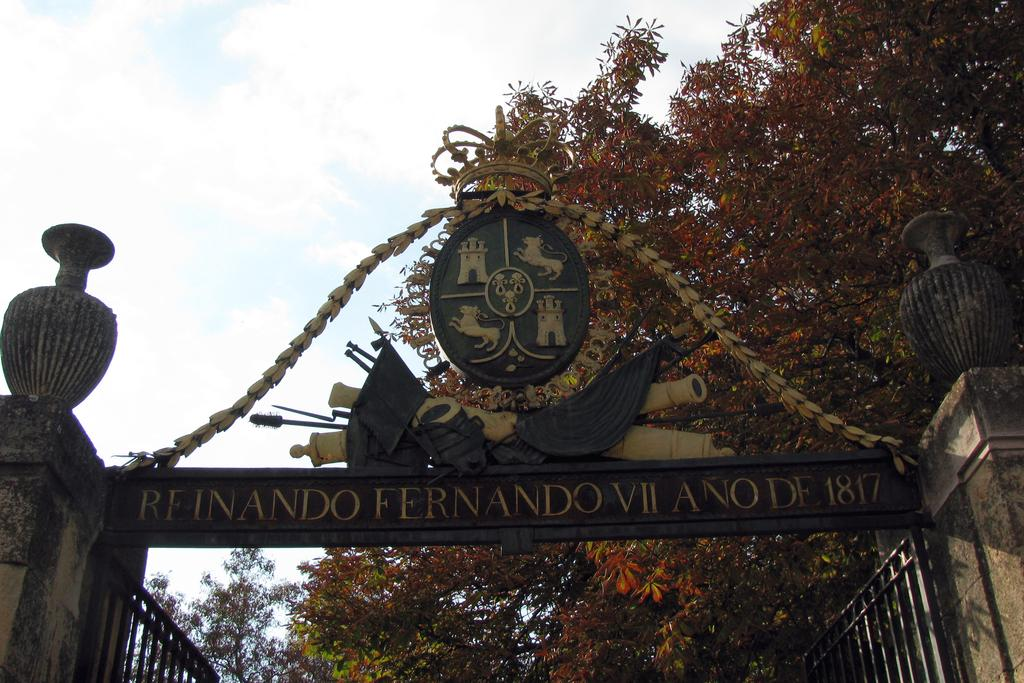<image>
Write a terse but informative summary of the picture. An entrance to something that reads REINANDO FERNANDO VII ANO DE 1817. 